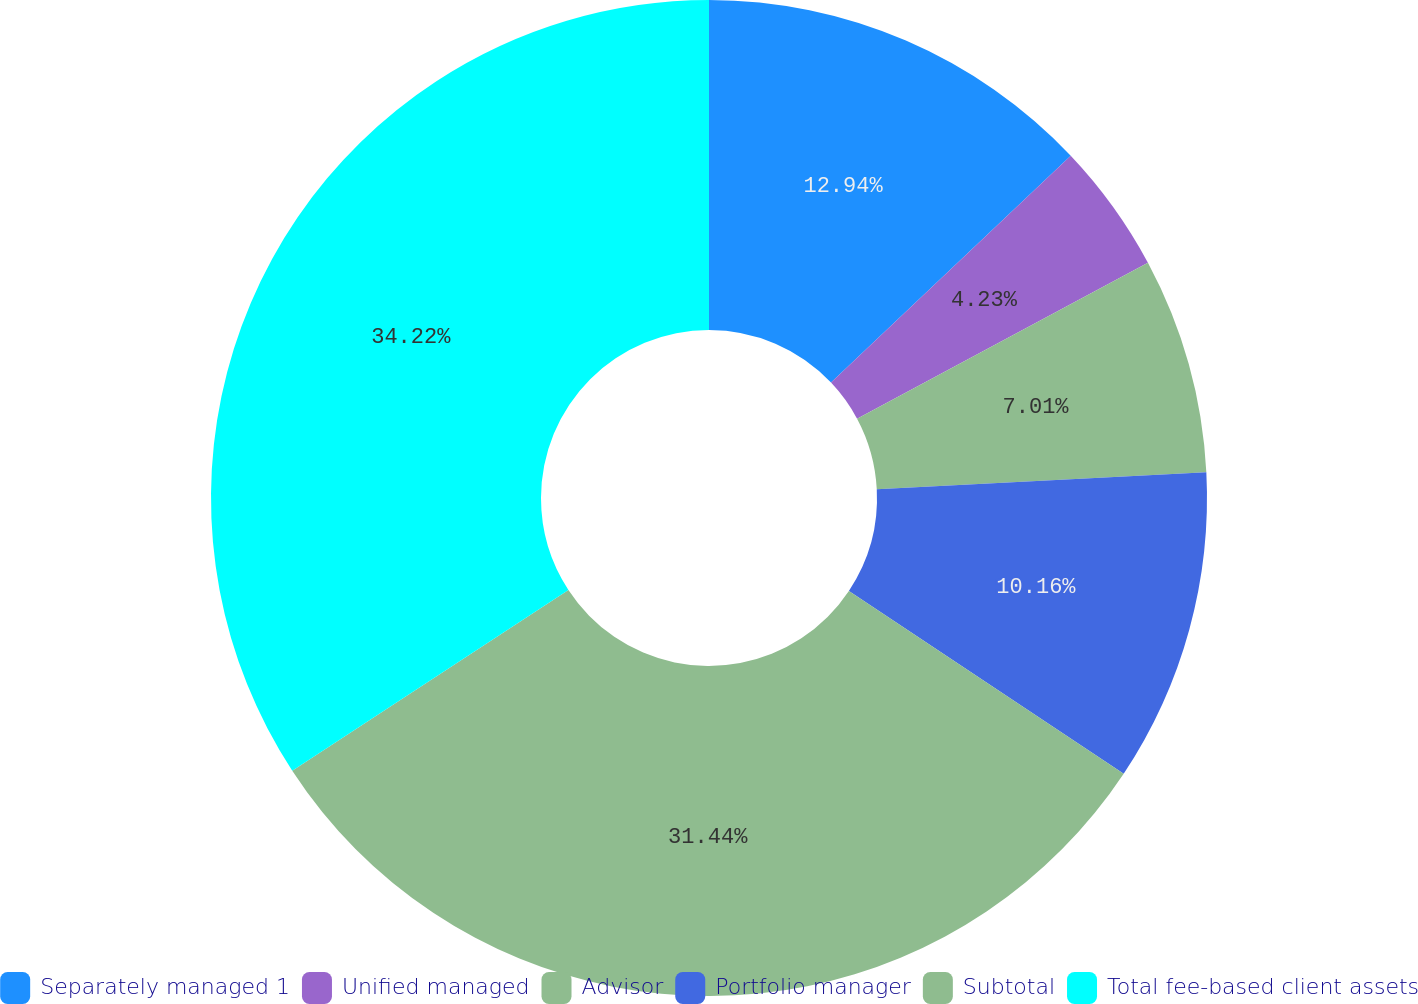Convert chart. <chart><loc_0><loc_0><loc_500><loc_500><pie_chart><fcel>Separately managed 1<fcel>Unified managed<fcel>Advisor<fcel>Portfolio manager<fcel>Subtotal<fcel>Total fee-based client assets<nl><fcel>12.94%<fcel>4.23%<fcel>7.01%<fcel>10.16%<fcel>31.44%<fcel>34.22%<nl></chart> 